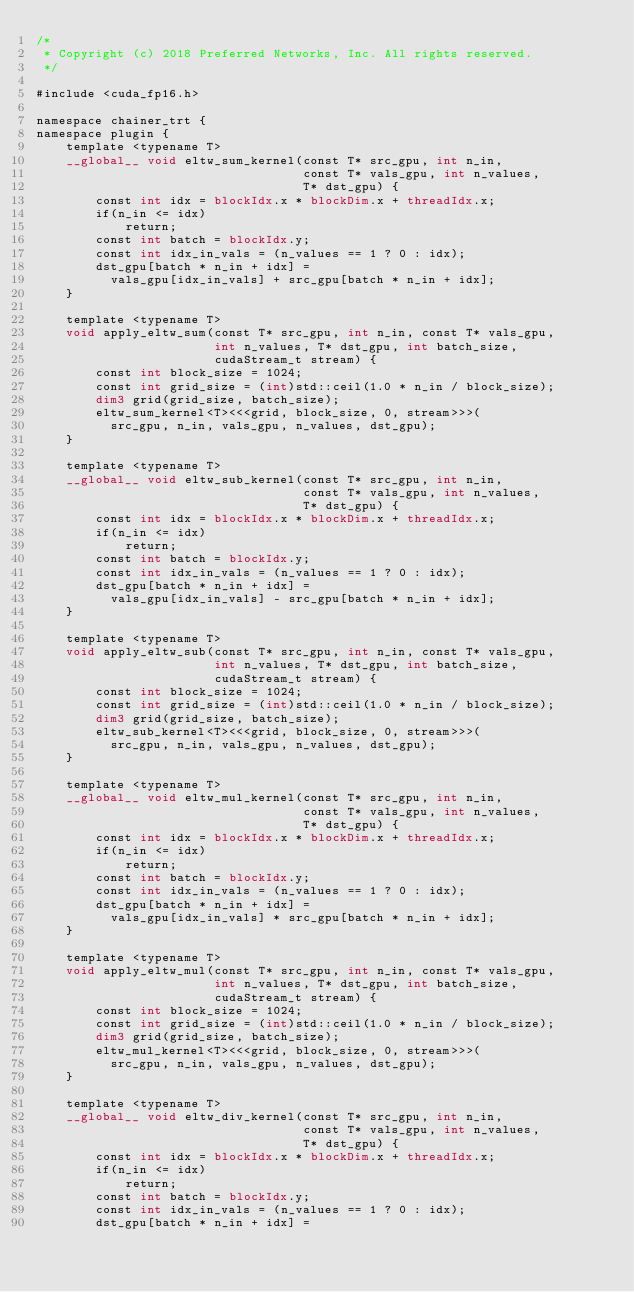Convert code to text. <code><loc_0><loc_0><loc_500><loc_500><_Cuda_>/*
 * Copyright (c) 2018 Preferred Networks, Inc. All rights reserved.
 */

#include <cuda_fp16.h>

namespace chainer_trt {
namespace plugin {
    template <typename T>
    __global__ void eltw_sum_kernel(const T* src_gpu, int n_in,
                                    const T* vals_gpu, int n_values,
                                    T* dst_gpu) {
        const int idx = blockIdx.x * blockDim.x + threadIdx.x;
        if(n_in <= idx)
            return;
        const int batch = blockIdx.y;
        const int idx_in_vals = (n_values == 1 ? 0 : idx);
        dst_gpu[batch * n_in + idx] =
          vals_gpu[idx_in_vals] + src_gpu[batch * n_in + idx];
    }

    template <typename T>
    void apply_eltw_sum(const T* src_gpu, int n_in, const T* vals_gpu,
                        int n_values, T* dst_gpu, int batch_size,
                        cudaStream_t stream) {
        const int block_size = 1024;
        const int grid_size = (int)std::ceil(1.0 * n_in / block_size);
        dim3 grid(grid_size, batch_size);
        eltw_sum_kernel<T><<<grid, block_size, 0, stream>>>(
          src_gpu, n_in, vals_gpu, n_values, dst_gpu);
    }

    template <typename T>
    __global__ void eltw_sub_kernel(const T* src_gpu, int n_in,
                                    const T* vals_gpu, int n_values,
                                    T* dst_gpu) {
        const int idx = blockIdx.x * blockDim.x + threadIdx.x;
        if(n_in <= idx)
            return;
        const int batch = blockIdx.y;
        const int idx_in_vals = (n_values == 1 ? 0 : idx);
        dst_gpu[batch * n_in + idx] =
          vals_gpu[idx_in_vals] - src_gpu[batch * n_in + idx];
    }

    template <typename T>
    void apply_eltw_sub(const T* src_gpu, int n_in, const T* vals_gpu,
                        int n_values, T* dst_gpu, int batch_size,
                        cudaStream_t stream) {
        const int block_size = 1024;
        const int grid_size = (int)std::ceil(1.0 * n_in / block_size);
        dim3 grid(grid_size, batch_size);
        eltw_sub_kernel<T><<<grid, block_size, 0, stream>>>(
          src_gpu, n_in, vals_gpu, n_values, dst_gpu);
    }

    template <typename T>
    __global__ void eltw_mul_kernel(const T* src_gpu, int n_in,
                                    const T* vals_gpu, int n_values,
                                    T* dst_gpu) {
        const int idx = blockIdx.x * blockDim.x + threadIdx.x;
        if(n_in <= idx)
            return;
        const int batch = blockIdx.y;
        const int idx_in_vals = (n_values == 1 ? 0 : idx);
        dst_gpu[batch * n_in + idx] =
          vals_gpu[idx_in_vals] * src_gpu[batch * n_in + idx];
    }

    template <typename T>
    void apply_eltw_mul(const T* src_gpu, int n_in, const T* vals_gpu,
                        int n_values, T* dst_gpu, int batch_size,
                        cudaStream_t stream) {
        const int block_size = 1024;
        const int grid_size = (int)std::ceil(1.0 * n_in / block_size);
        dim3 grid(grid_size, batch_size);
        eltw_mul_kernel<T><<<grid, block_size, 0, stream>>>(
          src_gpu, n_in, vals_gpu, n_values, dst_gpu);
    }

    template <typename T>
    __global__ void eltw_div_kernel(const T* src_gpu, int n_in,
                                    const T* vals_gpu, int n_values,
                                    T* dst_gpu) {
        const int idx = blockIdx.x * blockDim.x + threadIdx.x;
        if(n_in <= idx)
            return;
        const int batch = blockIdx.y;
        const int idx_in_vals = (n_values == 1 ? 0 : idx);
        dst_gpu[batch * n_in + idx] =</code> 